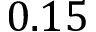Convert formula to latex. <formula><loc_0><loc_0><loc_500><loc_500>0 . 1 5</formula> 